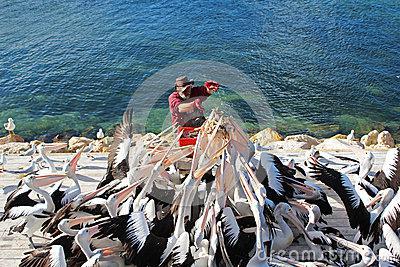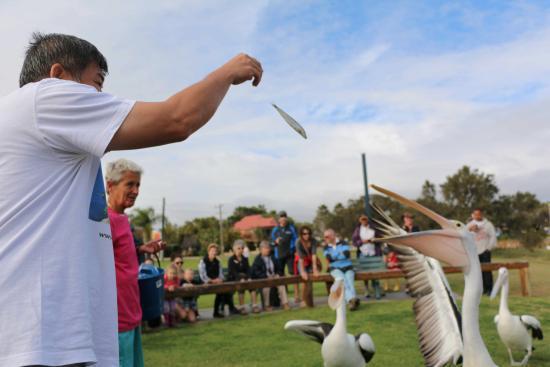The first image is the image on the left, the second image is the image on the right. Analyze the images presented: Is the assertion "In the image on the right, you can see exactly three of the birds, as there are none in the background." valid? Answer yes or no. Yes. 